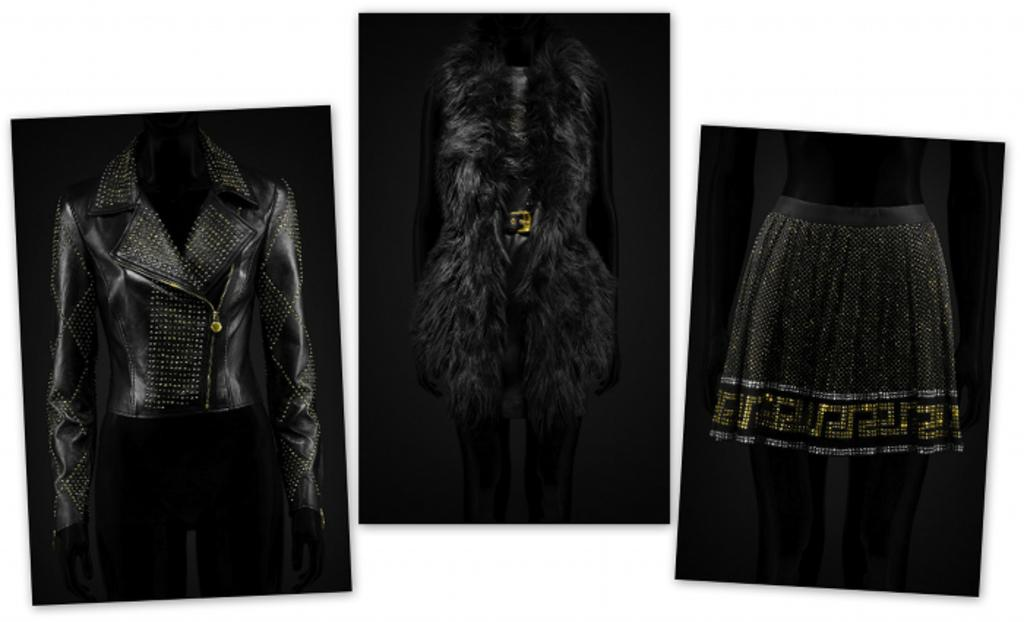How many mannequins are present in the image? There are three mannequins in the image. What are the mannequins wearing? The mannequins are wearing dresses. What is the color of the background in the image? The background of the image is white in color. What decision did the mannequin's mother make regarding the dresses in the image? There is no mention of a mother or a decision in the image, as it only features mannequins wearing dresses with a white background. 